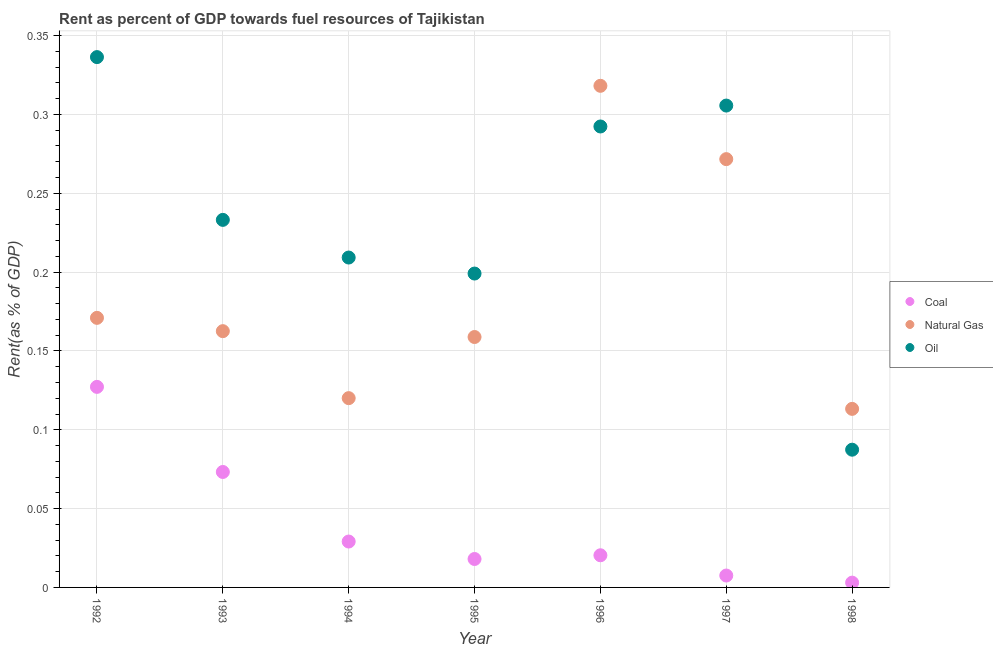How many different coloured dotlines are there?
Give a very brief answer. 3. Is the number of dotlines equal to the number of legend labels?
Your answer should be very brief. Yes. What is the rent towards oil in 1998?
Offer a very short reply. 0.09. Across all years, what is the maximum rent towards oil?
Provide a short and direct response. 0.34. Across all years, what is the minimum rent towards coal?
Make the answer very short. 0. In which year was the rent towards coal maximum?
Provide a succinct answer. 1992. In which year was the rent towards coal minimum?
Keep it short and to the point. 1998. What is the total rent towards coal in the graph?
Ensure brevity in your answer.  0.28. What is the difference between the rent towards oil in 1992 and that in 1994?
Your answer should be compact. 0.13. What is the difference between the rent towards coal in 1993 and the rent towards natural gas in 1996?
Ensure brevity in your answer.  -0.24. What is the average rent towards oil per year?
Provide a short and direct response. 0.24. In the year 1992, what is the difference between the rent towards coal and rent towards oil?
Make the answer very short. -0.21. What is the ratio of the rent towards natural gas in 1992 to that in 1998?
Your response must be concise. 1.51. What is the difference between the highest and the second highest rent towards coal?
Your answer should be compact. 0.05. What is the difference between the highest and the lowest rent towards natural gas?
Offer a very short reply. 0.2. In how many years, is the rent towards coal greater than the average rent towards coal taken over all years?
Your answer should be very brief. 2. Does the rent towards oil monotonically increase over the years?
Ensure brevity in your answer.  No. How many dotlines are there?
Make the answer very short. 3. How many legend labels are there?
Your response must be concise. 3. How are the legend labels stacked?
Make the answer very short. Vertical. What is the title of the graph?
Make the answer very short. Rent as percent of GDP towards fuel resources of Tajikistan. What is the label or title of the Y-axis?
Ensure brevity in your answer.  Rent(as % of GDP). What is the Rent(as % of GDP) of Coal in 1992?
Offer a very short reply. 0.13. What is the Rent(as % of GDP) of Natural Gas in 1992?
Make the answer very short. 0.17. What is the Rent(as % of GDP) in Oil in 1992?
Give a very brief answer. 0.34. What is the Rent(as % of GDP) in Coal in 1993?
Offer a very short reply. 0.07. What is the Rent(as % of GDP) in Natural Gas in 1993?
Give a very brief answer. 0.16. What is the Rent(as % of GDP) of Oil in 1993?
Provide a short and direct response. 0.23. What is the Rent(as % of GDP) in Coal in 1994?
Provide a succinct answer. 0.03. What is the Rent(as % of GDP) in Natural Gas in 1994?
Your answer should be compact. 0.12. What is the Rent(as % of GDP) of Oil in 1994?
Offer a terse response. 0.21. What is the Rent(as % of GDP) in Coal in 1995?
Your answer should be very brief. 0.02. What is the Rent(as % of GDP) in Natural Gas in 1995?
Make the answer very short. 0.16. What is the Rent(as % of GDP) of Oil in 1995?
Give a very brief answer. 0.2. What is the Rent(as % of GDP) in Coal in 1996?
Provide a short and direct response. 0.02. What is the Rent(as % of GDP) in Natural Gas in 1996?
Keep it short and to the point. 0.32. What is the Rent(as % of GDP) in Oil in 1996?
Give a very brief answer. 0.29. What is the Rent(as % of GDP) in Coal in 1997?
Offer a very short reply. 0.01. What is the Rent(as % of GDP) of Natural Gas in 1997?
Make the answer very short. 0.27. What is the Rent(as % of GDP) in Oil in 1997?
Make the answer very short. 0.31. What is the Rent(as % of GDP) in Coal in 1998?
Ensure brevity in your answer.  0. What is the Rent(as % of GDP) of Natural Gas in 1998?
Keep it short and to the point. 0.11. What is the Rent(as % of GDP) of Oil in 1998?
Your answer should be very brief. 0.09. Across all years, what is the maximum Rent(as % of GDP) of Coal?
Ensure brevity in your answer.  0.13. Across all years, what is the maximum Rent(as % of GDP) in Natural Gas?
Provide a succinct answer. 0.32. Across all years, what is the maximum Rent(as % of GDP) of Oil?
Make the answer very short. 0.34. Across all years, what is the minimum Rent(as % of GDP) of Coal?
Give a very brief answer. 0. Across all years, what is the minimum Rent(as % of GDP) in Natural Gas?
Make the answer very short. 0.11. Across all years, what is the minimum Rent(as % of GDP) in Oil?
Your response must be concise. 0.09. What is the total Rent(as % of GDP) in Coal in the graph?
Provide a succinct answer. 0.28. What is the total Rent(as % of GDP) in Natural Gas in the graph?
Give a very brief answer. 1.32. What is the total Rent(as % of GDP) of Oil in the graph?
Provide a succinct answer. 1.66. What is the difference between the Rent(as % of GDP) in Coal in 1992 and that in 1993?
Your answer should be compact. 0.05. What is the difference between the Rent(as % of GDP) of Natural Gas in 1992 and that in 1993?
Offer a very short reply. 0.01. What is the difference between the Rent(as % of GDP) in Oil in 1992 and that in 1993?
Provide a short and direct response. 0.1. What is the difference between the Rent(as % of GDP) of Coal in 1992 and that in 1994?
Ensure brevity in your answer.  0.1. What is the difference between the Rent(as % of GDP) of Natural Gas in 1992 and that in 1994?
Offer a very short reply. 0.05. What is the difference between the Rent(as % of GDP) in Oil in 1992 and that in 1994?
Offer a terse response. 0.13. What is the difference between the Rent(as % of GDP) of Coal in 1992 and that in 1995?
Your response must be concise. 0.11. What is the difference between the Rent(as % of GDP) of Natural Gas in 1992 and that in 1995?
Your response must be concise. 0.01. What is the difference between the Rent(as % of GDP) in Oil in 1992 and that in 1995?
Give a very brief answer. 0.14. What is the difference between the Rent(as % of GDP) of Coal in 1992 and that in 1996?
Your answer should be very brief. 0.11. What is the difference between the Rent(as % of GDP) of Natural Gas in 1992 and that in 1996?
Your response must be concise. -0.15. What is the difference between the Rent(as % of GDP) of Oil in 1992 and that in 1996?
Ensure brevity in your answer.  0.04. What is the difference between the Rent(as % of GDP) in Coal in 1992 and that in 1997?
Provide a short and direct response. 0.12. What is the difference between the Rent(as % of GDP) of Natural Gas in 1992 and that in 1997?
Provide a succinct answer. -0.1. What is the difference between the Rent(as % of GDP) of Oil in 1992 and that in 1997?
Ensure brevity in your answer.  0.03. What is the difference between the Rent(as % of GDP) in Coal in 1992 and that in 1998?
Make the answer very short. 0.12. What is the difference between the Rent(as % of GDP) in Natural Gas in 1992 and that in 1998?
Your response must be concise. 0.06. What is the difference between the Rent(as % of GDP) of Oil in 1992 and that in 1998?
Provide a succinct answer. 0.25. What is the difference between the Rent(as % of GDP) in Coal in 1993 and that in 1994?
Offer a very short reply. 0.04. What is the difference between the Rent(as % of GDP) in Natural Gas in 1993 and that in 1994?
Provide a succinct answer. 0.04. What is the difference between the Rent(as % of GDP) in Oil in 1993 and that in 1994?
Your answer should be compact. 0.02. What is the difference between the Rent(as % of GDP) of Coal in 1993 and that in 1995?
Make the answer very short. 0.06. What is the difference between the Rent(as % of GDP) of Natural Gas in 1993 and that in 1995?
Your answer should be very brief. 0. What is the difference between the Rent(as % of GDP) of Oil in 1993 and that in 1995?
Keep it short and to the point. 0.03. What is the difference between the Rent(as % of GDP) in Coal in 1993 and that in 1996?
Make the answer very short. 0.05. What is the difference between the Rent(as % of GDP) of Natural Gas in 1993 and that in 1996?
Your answer should be compact. -0.16. What is the difference between the Rent(as % of GDP) of Oil in 1993 and that in 1996?
Your response must be concise. -0.06. What is the difference between the Rent(as % of GDP) in Coal in 1993 and that in 1997?
Provide a short and direct response. 0.07. What is the difference between the Rent(as % of GDP) of Natural Gas in 1993 and that in 1997?
Provide a short and direct response. -0.11. What is the difference between the Rent(as % of GDP) of Oil in 1993 and that in 1997?
Give a very brief answer. -0.07. What is the difference between the Rent(as % of GDP) of Coal in 1993 and that in 1998?
Make the answer very short. 0.07. What is the difference between the Rent(as % of GDP) of Natural Gas in 1993 and that in 1998?
Provide a short and direct response. 0.05. What is the difference between the Rent(as % of GDP) in Oil in 1993 and that in 1998?
Provide a short and direct response. 0.15. What is the difference between the Rent(as % of GDP) in Coal in 1994 and that in 1995?
Your answer should be compact. 0.01. What is the difference between the Rent(as % of GDP) in Natural Gas in 1994 and that in 1995?
Your answer should be very brief. -0.04. What is the difference between the Rent(as % of GDP) in Oil in 1994 and that in 1995?
Ensure brevity in your answer.  0.01. What is the difference between the Rent(as % of GDP) of Coal in 1994 and that in 1996?
Your answer should be compact. 0.01. What is the difference between the Rent(as % of GDP) in Natural Gas in 1994 and that in 1996?
Provide a succinct answer. -0.2. What is the difference between the Rent(as % of GDP) of Oil in 1994 and that in 1996?
Provide a succinct answer. -0.08. What is the difference between the Rent(as % of GDP) in Coal in 1994 and that in 1997?
Your answer should be very brief. 0.02. What is the difference between the Rent(as % of GDP) in Natural Gas in 1994 and that in 1997?
Make the answer very short. -0.15. What is the difference between the Rent(as % of GDP) in Oil in 1994 and that in 1997?
Offer a terse response. -0.1. What is the difference between the Rent(as % of GDP) in Coal in 1994 and that in 1998?
Keep it short and to the point. 0.03. What is the difference between the Rent(as % of GDP) in Natural Gas in 1994 and that in 1998?
Provide a short and direct response. 0.01. What is the difference between the Rent(as % of GDP) of Oil in 1994 and that in 1998?
Your response must be concise. 0.12. What is the difference between the Rent(as % of GDP) of Coal in 1995 and that in 1996?
Make the answer very short. -0. What is the difference between the Rent(as % of GDP) in Natural Gas in 1995 and that in 1996?
Your response must be concise. -0.16. What is the difference between the Rent(as % of GDP) of Oil in 1995 and that in 1996?
Keep it short and to the point. -0.09. What is the difference between the Rent(as % of GDP) of Coal in 1995 and that in 1997?
Ensure brevity in your answer.  0.01. What is the difference between the Rent(as % of GDP) in Natural Gas in 1995 and that in 1997?
Provide a succinct answer. -0.11. What is the difference between the Rent(as % of GDP) in Oil in 1995 and that in 1997?
Offer a very short reply. -0.11. What is the difference between the Rent(as % of GDP) in Coal in 1995 and that in 1998?
Keep it short and to the point. 0.01. What is the difference between the Rent(as % of GDP) in Natural Gas in 1995 and that in 1998?
Ensure brevity in your answer.  0.05. What is the difference between the Rent(as % of GDP) in Oil in 1995 and that in 1998?
Keep it short and to the point. 0.11. What is the difference between the Rent(as % of GDP) of Coal in 1996 and that in 1997?
Provide a short and direct response. 0.01. What is the difference between the Rent(as % of GDP) in Natural Gas in 1996 and that in 1997?
Make the answer very short. 0.05. What is the difference between the Rent(as % of GDP) in Oil in 1996 and that in 1997?
Provide a short and direct response. -0.01. What is the difference between the Rent(as % of GDP) of Coal in 1996 and that in 1998?
Your answer should be compact. 0.02. What is the difference between the Rent(as % of GDP) in Natural Gas in 1996 and that in 1998?
Offer a terse response. 0.2. What is the difference between the Rent(as % of GDP) in Oil in 1996 and that in 1998?
Offer a terse response. 0.2. What is the difference between the Rent(as % of GDP) in Coal in 1997 and that in 1998?
Offer a very short reply. 0. What is the difference between the Rent(as % of GDP) in Natural Gas in 1997 and that in 1998?
Offer a very short reply. 0.16. What is the difference between the Rent(as % of GDP) in Oil in 1997 and that in 1998?
Offer a terse response. 0.22. What is the difference between the Rent(as % of GDP) of Coal in 1992 and the Rent(as % of GDP) of Natural Gas in 1993?
Offer a terse response. -0.04. What is the difference between the Rent(as % of GDP) in Coal in 1992 and the Rent(as % of GDP) in Oil in 1993?
Your answer should be very brief. -0.11. What is the difference between the Rent(as % of GDP) of Natural Gas in 1992 and the Rent(as % of GDP) of Oil in 1993?
Keep it short and to the point. -0.06. What is the difference between the Rent(as % of GDP) in Coal in 1992 and the Rent(as % of GDP) in Natural Gas in 1994?
Give a very brief answer. 0.01. What is the difference between the Rent(as % of GDP) of Coal in 1992 and the Rent(as % of GDP) of Oil in 1994?
Give a very brief answer. -0.08. What is the difference between the Rent(as % of GDP) of Natural Gas in 1992 and the Rent(as % of GDP) of Oil in 1994?
Make the answer very short. -0.04. What is the difference between the Rent(as % of GDP) in Coal in 1992 and the Rent(as % of GDP) in Natural Gas in 1995?
Make the answer very short. -0.03. What is the difference between the Rent(as % of GDP) in Coal in 1992 and the Rent(as % of GDP) in Oil in 1995?
Your response must be concise. -0.07. What is the difference between the Rent(as % of GDP) in Natural Gas in 1992 and the Rent(as % of GDP) in Oil in 1995?
Provide a short and direct response. -0.03. What is the difference between the Rent(as % of GDP) in Coal in 1992 and the Rent(as % of GDP) in Natural Gas in 1996?
Your answer should be compact. -0.19. What is the difference between the Rent(as % of GDP) in Coal in 1992 and the Rent(as % of GDP) in Oil in 1996?
Provide a succinct answer. -0.17. What is the difference between the Rent(as % of GDP) in Natural Gas in 1992 and the Rent(as % of GDP) in Oil in 1996?
Keep it short and to the point. -0.12. What is the difference between the Rent(as % of GDP) of Coal in 1992 and the Rent(as % of GDP) of Natural Gas in 1997?
Keep it short and to the point. -0.14. What is the difference between the Rent(as % of GDP) of Coal in 1992 and the Rent(as % of GDP) of Oil in 1997?
Your response must be concise. -0.18. What is the difference between the Rent(as % of GDP) of Natural Gas in 1992 and the Rent(as % of GDP) of Oil in 1997?
Keep it short and to the point. -0.13. What is the difference between the Rent(as % of GDP) in Coal in 1992 and the Rent(as % of GDP) in Natural Gas in 1998?
Your answer should be compact. 0.01. What is the difference between the Rent(as % of GDP) in Coal in 1992 and the Rent(as % of GDP) in Oil in 1998?
Your response must be concise. 0.04. What is the difference between the Rent(as % of GDP) of Natural Gas in 1992 and the Rent(as % of GDP) of Oil in 1998?
Keep it short and to the point. 0.08. What is the difference between the Rent(as % of GDP) of Coal in 1993 and the Rent(as % of GDP) of Natural Gas in 1994?
Your answer should be compact. -0.05. What is the difference between the Rent(as % of GDP) of Coal in 1993 and the Rent(as % of GDP) of Oil in 1994?
Give a very brief answer. -0.14. What is the difference between the Rent(as % of GDP) of Natural Gas in 1993 and the Rent(as % of GDP) of Oil in 1994?
Offer a very short reply. -0.05. What is the difference between the Rent(as % of GDP) of Coal in 1993 and the Rent(as % of GDP) of Natural Gas in 1995?
Your answer should be compact. -0.09. What is the difference between the Rent(as % of GDP) of Coal in 1993 and the Rent(as % of GDP) of Oil in 1995?
Ensure brevity in your answer.  -0.13. What is the difference between the Rent(as % of GDP) in Natural Gas in 1993 and the Rent(as % of GDP) in Oil in 1995?
Provide a short and direct response. -0.04. What is the difference between the Rent(as % of GDP) in Coal in 1993 and the Rent(as % of GDP) in Natural Gas in 1996?
Provide a short and direct response. -0.24. What is the difference between the Rent(as % of GDP) of Coal in 1993 and the Rent(as % of GDP) of Oil in 1996?
Ensure brevity in your answer.  -0.22. What is the difference between the Rent(as % of GDP) in Natural Gas in 1993 and the Rent(as % of GDP) in Oil in 1996?
Offer a very short reply. -0.13. What is the difference between the Rent(as % of GDP) in Coal in 1993 and the Rent(as % of GDP) in Natural Gas in 1997?
Ensure brevity in your answer.  -0.2. What is the difference between the Rent(as % of GDP) in Coal in 1993 and the Rent(as % of GDP) in Oil in 1997?
Ensure brevity in your answer.  -0.23. What is the difference between the Rent(as % of GDP) in Natural Gas in 1993 and the Rent(as % of GDP) in Oil in 1997?
Your response must be concise. -0.14. What is the difference between the Rent(as % of GDP) in Coal in 1993 and the Rent(as % of GDP) in Natural Gas in 1998?
Offer a very short reply. -0.04. What is the difference between the Rent(as % of GDP) of Coal in 1993 and the Rent(as % of GDP) of Oil in 1998?
Your answer should be very brief. -0.01. What is the difference between the Rent(as % of GDP) in Natural Gas in 1993 and the Rent(as % of GDP) in Oil in 1998?
Ensure brevity in your answer.  0.08. What is the difference between the Rent(as % of GDP) in Coal in 1994 and the Rent(as % of GDP) in Natural Gas in 1995?
Make the answer very short. -0.13. What is the difference between the Rent(as % of GDP) in Coal in 1994 and the Rent(as % of GDP) in Oil in 1995?
Provide a succinct answer. -0.17. What is the difference between the Rent(as % of GDP) of Natural Gas in 1994 and the Rent(as % of GDP) of Oil in 1995?
Give a very brief answer. -0.08. What is the difference between the Rent(as % of GDP) in Coal in 1994 and the Rent(as % of GDP) in Natural Gas in 1996?
Your response must be concise. -0.29. What is the difference between the Rent(as % of GDP) of Coal in 1994 and the Rent(as % of GDP) of Oil in 1996?
Offer a very short reply. -0.26. What is the difference between the Rent(as % of GDP) of Natural Gas in 1994 and the Rent(as % of GDP) of Oil in 1996?
Provide a short and direct response. -0.17. What is the difference between the Rent(as % of GDP) in Coal in 1994 and the Rent(as % of GDP) in Natural Gas in 1997?
Make the answer very short. -0.24. What is the difference between the Rent(as % of GDP) in Coal in 1994 and the Rent(as % of GDP) in Oil in 1997?
Provide a succinct answer. -0.28. What is the difference between the Rent(as % of GDP) in Natural Gas in 1994 and the Rent(as % of GDP) in Oil in 1997?
Give a very brief answer. -0.19. What is the difference between the Rent(as % of GDP) of Coal in 1994 and the Rent(as % of GDP) of Natural Gas in 1998?
Provide a short and direct response. -0.08. What is the difference between the Rent(as % of GDP) of Coal in 1994 and the Rent(as % of GDP) of Oil in 1998?
Offer a very short reply. -0.06. What is the difference between the Rent(as % of GDP) of Natural Gas in 1994 and the Rent(as % of GDP) of Oil in 1998?
Your answer should be very brief. 0.03. What is the difference between the Rent(as % of GDP) of Coal in 1995 and the Rent(as % of GDP) of Natural Gas in 1996?
Provide a short and direct response. -0.3. What is the difference between the Rent(as % of GDP) of Coal in 1995 and the Rent(as % of GDP) of Oil in 1996?
Your response must be concise. -0.27. What is the difference between the Rent(as % of GDP) of Natural Gas in 1995 and the Rent(as % of GDP) of Oil in 1996?
Provide a succinct answer. -0.13. What is the difference between the Rent(as % of GDP) in Coal in 1995 and the Rent(as % of GDP) in Natural Gas in 1997?
Provide a succinct answer. -0.25. What is the difference between the Rent(as % of GDP) in Coal in 1995 and the Rent(as % of GDP) in Oil in 1997?
Ensure brevity in your answer.  -0.29. What is the difference between the Rent(as % of GDP) in Natural Gas in 1995 and the Rent(as % of GDP) in Oil in 1997?
Provide a short and direct response. -0.15. What is the difference between the Rent(as % of GDP) of Coal in 1995 and the Rent(as % of GDP) of Natural Gas in 1998?
Ensure brevity in your answer.  -0.1. What is the difference between the Rent(as % of GDP) in Coal in 1995 and the Rent(as % of GDP) in Oil in 1998?
Provide a succinct answer. -0.07. What is the difference between the Rent(as % of GDP) of Natural Gas in 1995 and the Rent(as % of GDP) of Oil in 1998?
Your answer should be compact. 0.07. What is the difference between the Rent(as % of GDP) in Coal in 1996 and the Rent(as % of GDP) in Natural Gas in 1997?
Offer a very short reply. -0.25. What is the difference between the Rent(as % of GDP) in Coal in 1996 and the Rent(as % of GDP) in Oil in 1997?
Keep it short and to the point. -0.29. What is the difference between the Rent(as % of GDP) of Natural Gas in 1996 and the Rent(as % of GDP) of Oil in 1997?
Provide a short and direct response. 0.01. What is the difference between the Rent(as % of GDP) of Coal in 1996 and the Rent(as % of GDP) of Natural Gas in 1998?
Your answer should be very brief. -0.09. What is the difference between the Rent(as % of GDP) of Coal in 1996 and the Rent(as % of GDP) of Oil in 1998?
Make the answer very short. -0.07. What is the difference between the Rent(as % of GDP) of Natural Gas in 1996 and the Rent(as % of GDP) of Oil in 1998?
Ensure brevity in your answer.  0.23. What is the difference between the Rent(as % of GDP) in Coal in 1997 and the Rent(as % of GDP) in Natural Gas in 1998?
Give a very brief answer. -0.11. What is the difference between the Rent(as % of GDP) of Coal in 1997 and the Rent(as % of GDP) of Oil in 1998?
Provide a short and direct response. -0.08. What is the difference between the Rent(as % of GDP) of Natural Gas in 1997 and the Rent(as % of GDP) of Oil in 1998?
Provide a short and direct response. 0.18. What is the average Rent(as % of GDP) of Coal per year?
Your answer should be very brief. 0.04. What is the average Rent(as % of GDP) in Natural Gas per year?
Provide a succinct answer. 0.19. What is the average Rent(as % of GDP) in Oil per year?
Make the answer very short. 0.24. In the year 1992, what is the difference between the Rent(as % of GDP) in Coal and Rent(as % of GDP) in Natural Gas?
Make the answer very short. -0.04. In the year 1992, what is the difference between the Rent(as % of GDP) of Coal and Rent(as % of GDP) of Oil?
Your answer should be very brief. -0.21. In the year 1992, what is the difference between the Rent(as % of GDP) in Natural Gas and Rent(as % of GDP) in Oil?
Provide a succinct answer. -0.17. In the year 1993, what is the difference between the Rent(as % of GDP) in Coal and Rent(as % of GDP) in Natural Gas?
Give a very brief answer. -0.09. In the year 1993, what is the difference between the Rent(as % of GDP) in Coal and Rent(as % of GDP) in Oil?
Provide a succinct answer. -0.16. In the year 1993, what is the difference between the Rent(as % of GDP) in Natural Gas and Rent(as % of GDP) in Oil?
Give a very brief answer. -0.07. In the year 1994, what is the difference between the Rent(as % of GDP) of Coal and Rent(as % of GDP) of Natural Gas?
Ensure brevity in your answer.  -0.09. In the year 1994, what is the difference between the Rent(as % of GDP) in Coal and Rent(as % of GDP) in Oil?
Your answer should be very brief. -0.18. In the year 1994, what is the difference between the Rent(as % of GDP) in Natural Gas and Rent(as % of GDP) in Oil?
Make the answer very short. -0.09. In the year 1995, what is the difference between the Rent(as % of GDP) of Coal and Rent(as % of GDP) of Natural Gas?
Offer a very short reply. -0.14. In the year 1995, what is the difference between the Rent(as % of GDP) in Coal and Rent(as % of GDP) in Oil?
Provide a short and direct response. -0.18. In the year 1995, what is the difference between the Rent(as % of GDP) in Natural Gas and Rent(as % of GDP) in Oil?
Offer a terse response. -0.04. In the year 1996, what is the difference between the Rent(as % of GDP) of Coal and Rent(as % of GDP) of Natural Gas?
Keep it short and to the point. -0.3. In the year 1996, what is the difference between the Rent(as % of GDP) of Coal and Rent(as % of GDP) of Oil?
Keep it short and to the point. -0.27. In the year 1996, what is the difference between the Rent(as % of GDP) in Natural Gas and Rent(as % of GDP) in Oil?
Offer a very short reply. 0.03. In the year 1997, what is the difference between the Rent(as % of GDP) of Coal and Rent(as % of GDP) of Natural Gas?
Give a very brief answer. -0.26. In the year 1997, what is the difference between the Rent(as % of GDP) of Coal and Rent(as % of GDP) of Oil?
Your answer should be compact. -0.3. In the year 1997, what is the difference between the Rent(as % of GDP) in Natural Gas and Rent(as % of GDP) in Oil?
Give a very brief answer. -0.03. In the year 1998, what is the difference between the Rent(as % of GDP) in Coal and Rent(as % of GDP) in Natural Gas?
Your answer should be very brief. -0.11. In the year 1998, what is the difference between the Rent(as % of GDP) of Coal and Rent(as % of GDP) of Oil?
Provide a short and direct response. -0.08. In the year 1998, what is the difference between the Rent(as % of GDP) of Natural Gas and Rent(as % of GDP) of Oil?
Make the answer very short. 0.03. What is the ratio of the Rent(as % of GDP) in Coal in 1992 to that in 1993?
Your answer should be very brief. 1.74. What is the ratio of the Rent(as % of GDP) in Natural Gas in 1992 to that in 1993?
Offer a terse response. 1.05. What is the ratio of the Rent(as % of GDP) of Oil in 1992 to that in 1993?
Offer a terse response. 1.44. What is the ratio of the Rent(as % of GDP) of Coal in 1992 to that in 1994?
Your answer should be very brief. 4.37. What is the ratio of the Rent(as % of GDP) in Natural Gas in 1992 to that in 1994?
Keep it short and to the point. 1.42. What is the ratio of the Rent(as % of GDP) of Oil in 1992 to that in 1994?
Your answer should be very brief. 1.61. What is the ratio of the Rent(as % of GDP) of Coal in 1992 to that in 1995?
Provide a short and direct response. 7.05. What is the ratio of the Rent(as % of GDP) of Natural Gas in 1992 to that in 1995?
Provide a succinct answer. 1.08. What is the ratio of the Rent(as % of GDP) in Oil in 1992 to that in 1995?
Your answer should be compact. 1.69. What is the ratio of the Rent(as % of GDP) in Coal in 1992 to that in 1996?
Your answer should be compact. 6.24. What is the ratio of the Rent(as % of GDP) in Natural Gas in 1992 to that in 1996?
Your answer should be compact. 0.54. What is the ratio of the Rent(as % of GDP) in Oil in 1992 to that in 1996?
Provide a succinct answer. 1.15. What is the ratio of the Rent(as % of GDP) in Coal in 1992 to that in 1997?
Your answer should be compact. 16.86. What is the ratio of the Rent(as % of GDP) in Natural Gas in 1992 to that in 1997?
Provide a succinct answer. 0.63. What is the ratio of the Rent(as % of GDP) in Oil in 1992 to that in 1997?
Your response must be concise. 1.1. What is the ratio of the Rent(as % of GDP) of Coal in 1992 to that in 1998?
Keep it short and to the point. 41.89. What is the ratio of the Rent(as % of GDP) in Natural Gas in 1992 to that in 1998?
Your answer should be compact. 1.51. What is the ratio of the Rent(as % of GDP) in Oil in 1992 to that in 1998?
Your response must be concise. 3.85. What is the ratio of the Rent(as % of GDP) of Coal in 1993 to that in 1994?
Ensure brevity in your answer.  2.52. What is the ratio of the Rent(as % of GDP) in Natural Gas in 1993 to that in 1994?
Provide a succinct answer. 1.35. What is the ratio of the Rent(as % of GDP) in Oil in 1993 to that in 1994?
Ensure brevity in your answer.  1.11. What is the ratio of the Rent(as % of GDP) of Coal in 1993 to that in 1995?
Make the answer very short. 4.06. What is the ratio of the Rent(as % of GDP) in Natural Gas in 1993 to that in 1995?
Provide a succinct answer. 1.02. What is the ratio of the Rent(as % of GDP) of Oil in 1993 to that in 1995?
Keep it short and to the point. 1.17. What is the ratio of the Rent(as % of GDP) in Coal in 1993 to that in 1996?
Offer a very short reply. 3.59. What is the ratio of the Rent(as % of GDP) of Natural Gas in 1993 to that in 1996?
Ensure brevity in your answer.  0.51. What is the ratio of the Rent(as % of GDP) in Oil in 1993 to that in 1996?
Give a very brief answer. 0.8. What is the ratio of the Rent(as % of GDP) of Coal in 1993 to that in 1997?
Provide a succinct answer. 9.71. What is the ratio of the Rent(as % of GDP) of Natural Gas in 1993 to that in 1997?
Your answer should be compact. 0.6. What is the ratio of the Rent(as % of GDP) in Oil in 1993 to that in 1997?
Your answer should be very brief. 0.76. What is the ratio of the Rent(as % of GDP) of Coal in 1993 to that in 1998?
Your response must be concise. 24.12. What is the ratio of the Rent(as % of GDP) of Natural Gas in 1993 to that in 1998?
Ensure brevity in your answer.  1.44. What is the ratio of the Rent(as % of GDP) in Oil in 1993 to that in 1998?
Your answer should be very brief. 2.67. What is the ratio of the Rent(as % of GDP) of Coal in 1994 to that in 1995?
Give a very brief answer. 1.61. What is the ratio of the Rent(as % of GDP) in Natural Gas in 1994 to that in 1995?
Keep it short and to the point. 0.76. What is the ratio of the Rent(as % of GDP) in Oil in 1994 to that in 1995?
Your answer should be compact. 1.05. What is the ratio of the Rent(as % of GDP) in Coal in 1994 to that in 1996?
Offer a very short reply. 1.43. What is the ratio of the Rent(as % of GDP) in Natural Gas in 1994 to that in 1996?
Offer a terse response. 0.38. What is the ratio of the Rent(as % of GDP) of Oil in 1994 to that in 1996?
Make the answer very short. 0.72. What is the ratio of the Rent(as % of GDP) of Coal in 1994 to that in 1997?
Ensure brevity in your answer.  3.86. What is the ratio of the Rent(as % of GDP) of Natural Gas in 1994 to that in 1997?
Ensure brevity in your answer.  0.44. What is the ratio of the Rent(as % of GDP) in Oil in 1994 to that in 1997?
Your answer should be compact. 0.68. What is the ratio of the Rent(as % of GDP) of Coal in 1994 to that in 1998?
Offer a terse response. 9.59. What is the ratio of the Rent(as % of GDP) of Natural Gas in 1994 to that in 1998?
Make the answer very short. 1.06. What is the ratio of the Rent(as % of GDP) of Oil in 1994 to that in 1998?
Offer a terse response. 2.4. What is the ratio of the Rent(as % of GDP) of Coal in 1995 to that in 1996?
Your answer should be very brief. 0.88. What is the ratio of the Rent(as % of GDP) of Natural Gas in 1995 to that in 1996?
Offer a very short reply. 0.5. What is the ratio of the Rent(as % of GDP) in Oil in 1995 to that in 1996?
Make the answer very short. 0.68. What is the ratio of the Rent(as % of GDP) of Coal in 1995 to that in 1997?
Provide a short and direct response. 2.39. What is the ratio of the Rent(as % of GDP) of Natural Gas in 1995 to that in 1997?
Keep it short and to the point. 0.58. What is the ratio of the Rent(as % of GDP) in Oil in 1995 to that in 1997?
Provide a succinct answer. 0.65. What is the ratio of the Rent(as % of GDP) in Coal in 1995 to that in 1998?
Offer a terse response. 5.94. What is the ratio of the Rent(as % of GDP) of Natural Gas in 1995 to that in 1998?
Your answer should be compact. 1.4. What is the ratio of the Rent(as % of GDP) of Oil in 1995 to that in 1998?
Make the answer very short. 2.28. What is the ratio of the Rent(as % of GDP) in Coal in 1996 to that in 1997?
Keep it short and to the point. 2.7. What is the ratio of the Rent(as % of GDP) of Natural Gas in 1996 to that in 1997?
Offer a terse response. 1.17. What is the ratio of the Rent(as % of GDP) in Oil in 1996 to that in 1997?
Offer a terse response. 0.96. What is the ratio of the Rent(as % of GDP) of Coal in 1996 to that in 1998?
Provide a short and direct response. 6.72. What is the ratio of the Rent(as % of GDP) of Natural Gas in 1996 to that in 1998?
Ensure brevity in your answer.  2.81. What is the ratio of the Rent(as % of GDP) in Oil in 1996 to that in 1998?
Offer a very short reply. 3.35. What is the ratio of the Rent(as % of GDP) of Coal in 1997 to that in 1998?
Provide a succinct answer. 2.48. What is the ratio of the Rent(as % of GDP) in Natural Gas in 1997 to that in 1998?
Make the answer very short. 2.4. What is the ratio of the Rent(as % of GDP) of Oil in 1997 to that in 1998?
Offer a very short reply. 3.5. What is the difference between the highest and the second highest Rent(as % of GDP) of Coal?
Keep it short and to the point. 0.05. What is the difference between the highest and the second highest Rent(as % of GDP) in Natural Gas?
Your answer should be very brief. 0.05. What is the difference between the highest and the second highest Rent(as % of GDP) of Oil?
Offer a very short reply. 0.03. What is the difference between the highest and the lowest Rent(as % of GDP) of Coal?
Provide a short and direct response. 0.12. What is the difference between the highest and the lowest Rent(as % of GDP) in Natural Gas?
Your answer should be very brief. 0.2. What is the difference between the highest and the lowest Rent(as % of GDP) of Oil?
Your response must be concise. 0.25. 